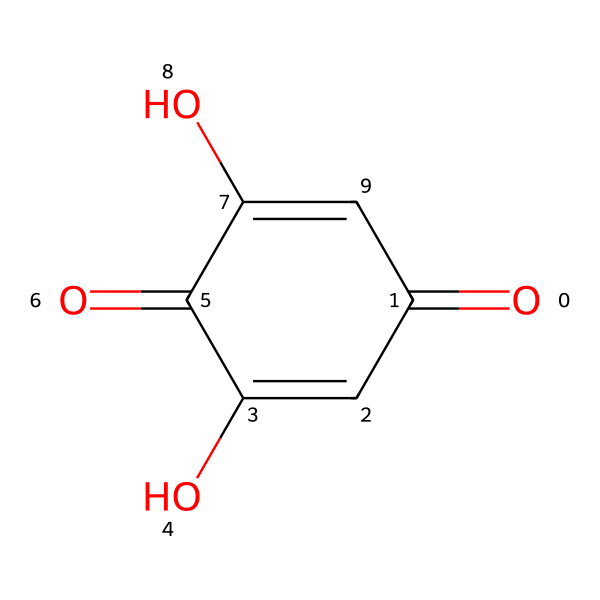How many carbon atoms are in the structure? The SMILES notation indicates a cyclic compound with one ring. By analyzing the carbon atoms in the structure, we see there are six carbon atoms connected in a ring.
Answer: six What is the functional group present in this compound? By examining the structure represented by the SMILES notation, we can identify that it contains carbonyl (C=O) groups as well as hydroxyl (C-OH) groups, indicating multiple functional groups.
Answer: carbonyl and hydroxyl What type of bonding is predominant in this chemical? The structure shows multiple double bonds between carbon atoms as well as single bonds connecting various atoms. This indicates that both sigma (σ) and pi (π) bonds are present, with double bonds being significant in this hydrocarbon.
Answer: sigma and pi bonds What does the presence of hydroxyl groups suggest about the dye's solubility? Hydroxyl groups are known to be polar, leading to an increased ability for this compound to interact with water, indicating higher solubility in water, which is relevant to dye applications.
Answer: higher solubility in water What is the significance of the carbonyl groups in this dye? Carbonyl groups are often involved in color formation and chemical reactivity, affecting how the dye interacts with fibers in textiles, enhancing its application in traditional textiles.
Answer: enhances color and reactivity How many rings are present in the molecular structure? The SMILES notation indicates that the compound contains a single ring structure, as seen from the numbering of atoms that signifies the start and end of the ring.
Answer: one ring 